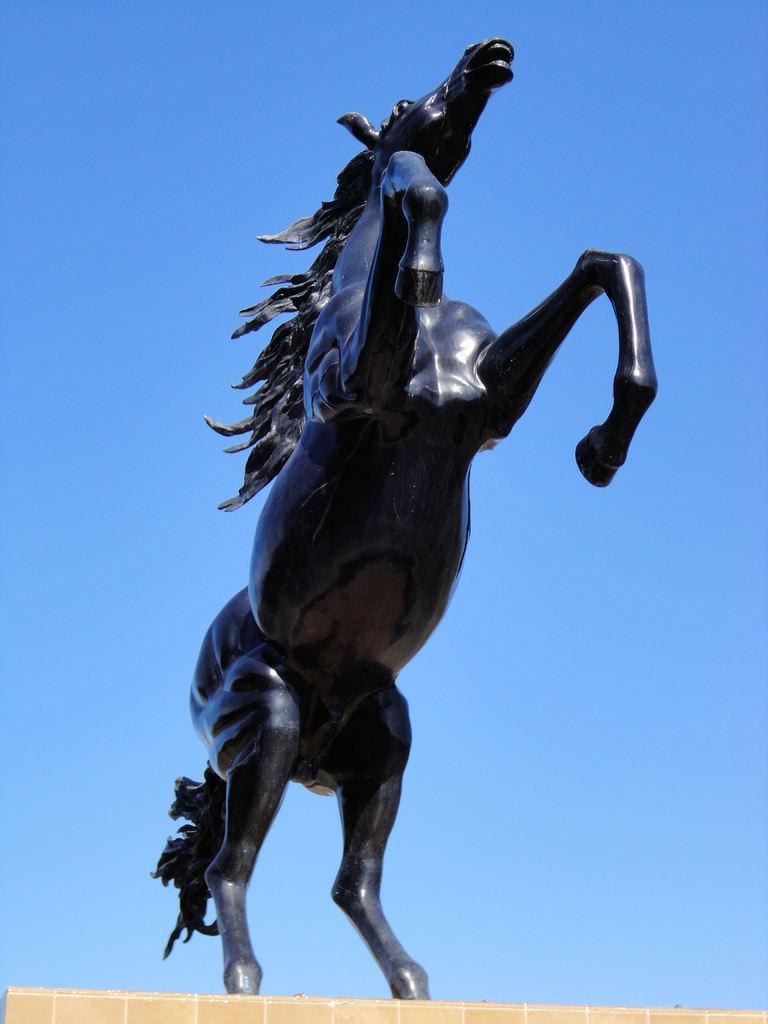In one or two sentences, can you explain what this image depicts? In this image, in the middle, we can see a statue of an animal. In the background, we can see blue color. At the bottom, we can see yellow color. 